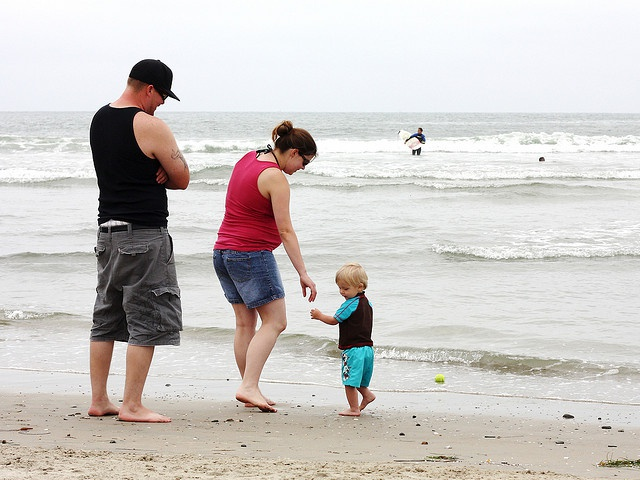Describe the objects in this image and their specific colors. I can see people in white, black, gray, brown, and tan tones, people in white, brown, tan, and black tones, people in white, black, brown, teal, and maroon tones, surfboard in white, ivory, pink, darkgray, and beige tones, and people in white, black, lightgray, gray, and darkgray tones in this image. 